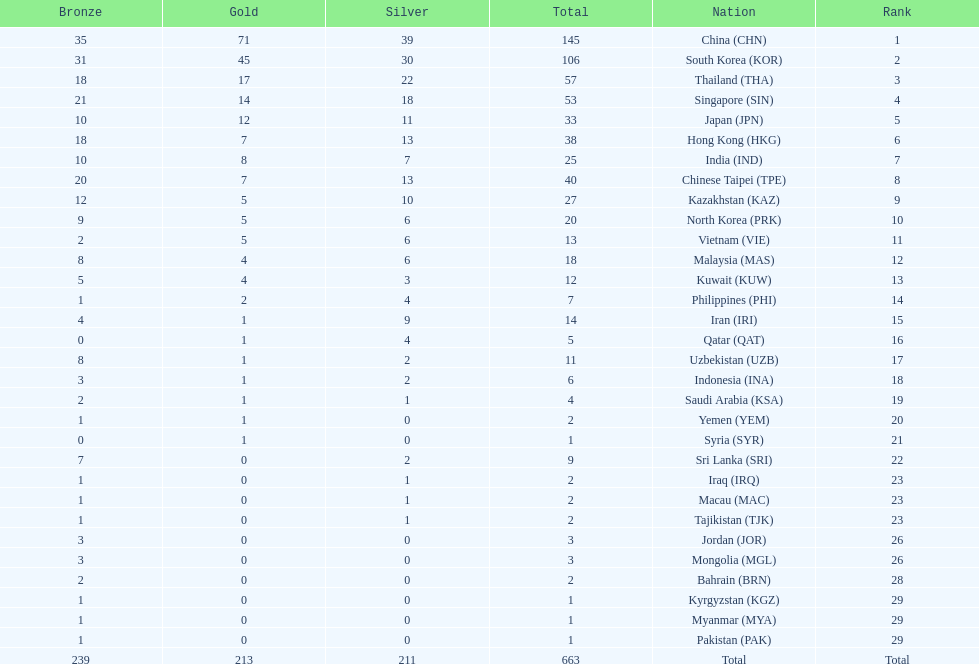Could you help me parse every detail presented in this table? {'header': ['Bronze', 'Gold', 'Silver', 'Total', 'Nation', 'Rank'], 'rows': [['35', '71', '39', '145', 'China\xa0(CHN)', '1'], ['31', '45', '30', '106', 'South Korea\xa0(KOR)', '2'], ['18', '17', '22', '57', 'Thailand\xa0(THA)', '3'], ['21', '14', '18', '53', 'Singapore\xa0(SIN)', '4'], ['10', '12', '11', '33', 'Japan\xa0(JPN)', '5'], ['18', '7', '13', '38', 'Hong Kong\xa0(HKG)', '6'], ['10', '8', '7', '25', 'India\xa0(IND)', '7'], ['20', '7', '13', '40', 'Chinese Taipei\xa0(TPE)', '8'], ['12', '5', '10', '27', 'Kazakhstan\xa0(KAZ)', '9'], ['9', '5', '6', '20', 'North Korea\xa0(PRK)', '10'], ['2', '5', '6', '13', 'Vietnam\xa0(VIE)', '11'], ['8', '4', '6', '18', 'Malaysia\xa0(MAS)', '12'], ['5', '4', '3', '12', 'Kuwait\xa0(KUW)', '13'], ['1', '2', '4', '7', 'Philippines\xa0(PHI)', '14'], ['4', '1', '9', '14', 'Iran\xa0(IRI)', '15'], ['0', '1', '4', '5', 'Qatar\xa0(QAT)', '16'], ['8', '1', '2', '11', 'Uzbekistan\xa0(UZB)', '17'], ['3', '1', '2', '6', 'Indonesia\xa0(INA)', '18'], ['2', '1', '1', '4', 'Saudi Arabia\xa0(KSA)', '19'], ['1', '1', '0', '2', 'Yemen\xa0(YEM)', '20'], ['0', '1', '0', '1', 'Syria\xa0(SYR)', '21'], ['7', '0', '2', '9', 'Sri Lanka\xa0(SRI)', '22'], ['1', '0', '1', '2', 'Iraq\xa0(IRQ)', '23'], ['1', '0', '1', '2', 'Macau\xa0(MAC)', '23'], ['1', '0', '1', '2', 'Tajikistan\xa0(TJK)', '23'], ['3', '0', '0', '3', 'Jordan\xa0(JOR)', '26'], ['3', '0', '0', '3', 'Mongolia\xa0(MGL)', '26'], ['2', '0', '0', '2', 'Bahrain\xa0(BRN)', '28'], ['1', '0', '0', '1', 'Kyrgyzstan\xa0(KGZ)', '29'], ['1', '0', '0', '1', 'Myanmar\xa0(MYA)', '29'], ['1', '0', '0', '1', 'Pakistan\xa0(PAK)', '29'], ['239', '213', '211', '663', 'Total', 'Total']]} What is the difference between the total amount of medals won by qatar and indonesia? 1. 